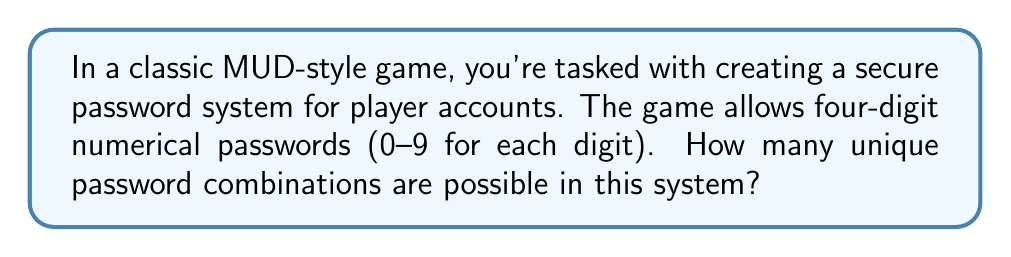What is the answer to this math problem? Let's approach this step-by-step:

1) Each digit in the password can be any number from 0 to 9. This means we have 10 choices for each digit.

2) We need to determine the total number of ways to choose 4 digits, where each digit can be any of the 10 possible numbers.

3) This is a perfect scenario for applying the multiplication principle of counting. When we have a series of independent choices, we multiply the number of possibilities for each choice.

4) In this case:
   - For the first digit, we have 10 choices
   - For the second digit, we again have 10 choices
   - For the third digit, we again have 10 choices
   - For the fourth digit, we again have 10 choices

5) Therefore, the total number of possible combinations is:

   $$ 10 \times 10 \times 10 \times 10 = 10^4 $$

6) We can calculate this:

   $$ 10^4 = 10,000 $$

Thus, there are 10,000 possible unique combinations for a four-digit numerical password in this MUD-style game.
Answer: 10,000 